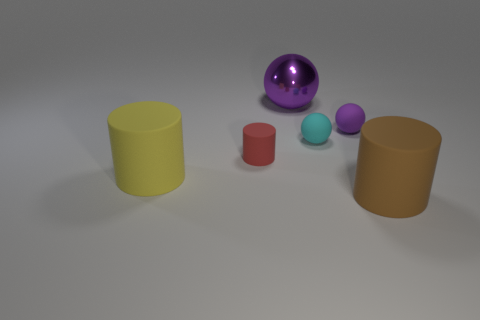How many purple balls must be subtracted to get 1 purple balls? 1 Subtract all green blocks. How many purple balls are left? 2 Subtract all purple balls. How many balls are left? 1 Add 2 big things. How many objects exist? 8 Subtract all cyan cylinders. Subtract all purple blocks. How many cylinders are left? 3 Add 5 brown rubber things. How many brown rubber things exist? 6 Subtract 0 blue cubes. How many objects are left? 6 Subtract all metal spheres. Subtract all large blue rubber cubes. How many objects are left? 5 Add 6 cyan rubber spheres. How many cyan rubber spheres are left? 7 